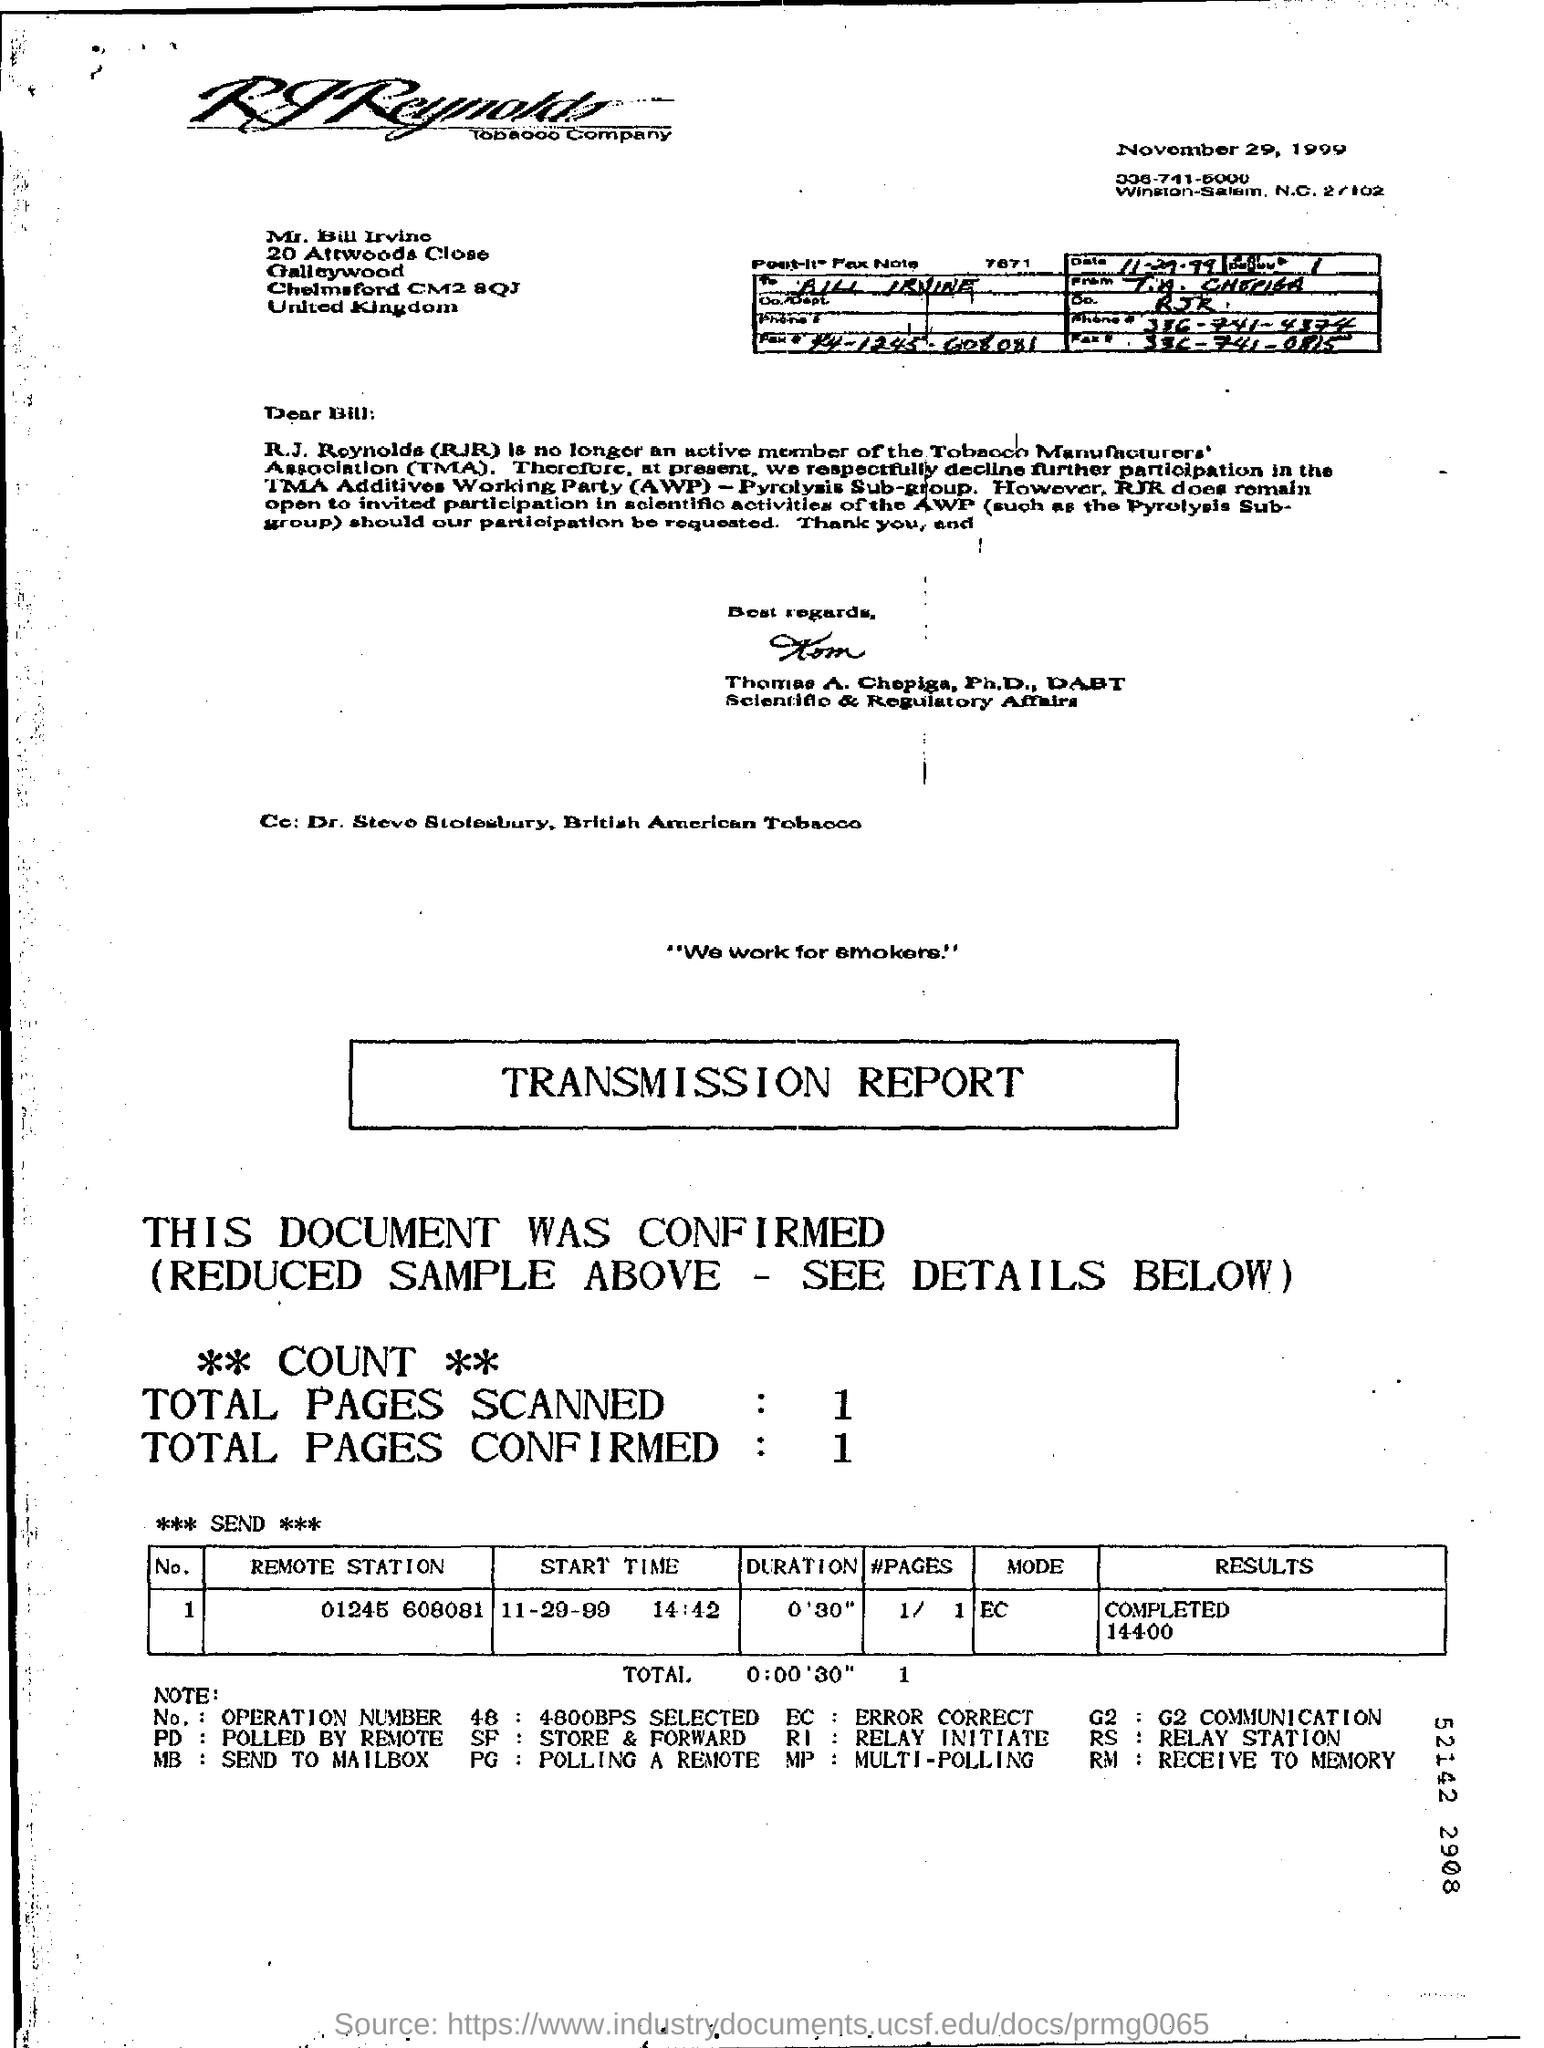How many total number of pages are scanned?
Ensure brevity in your answer.  1. How many total number of pages are confirmed?
Give a very brief answer. 1. What is the start time mentioned in the transmission report?
Your answer should be compact. 11-29-99 14:42. What is the mode mentioned in the transmission report?
Your answer should be very brief. EC. 